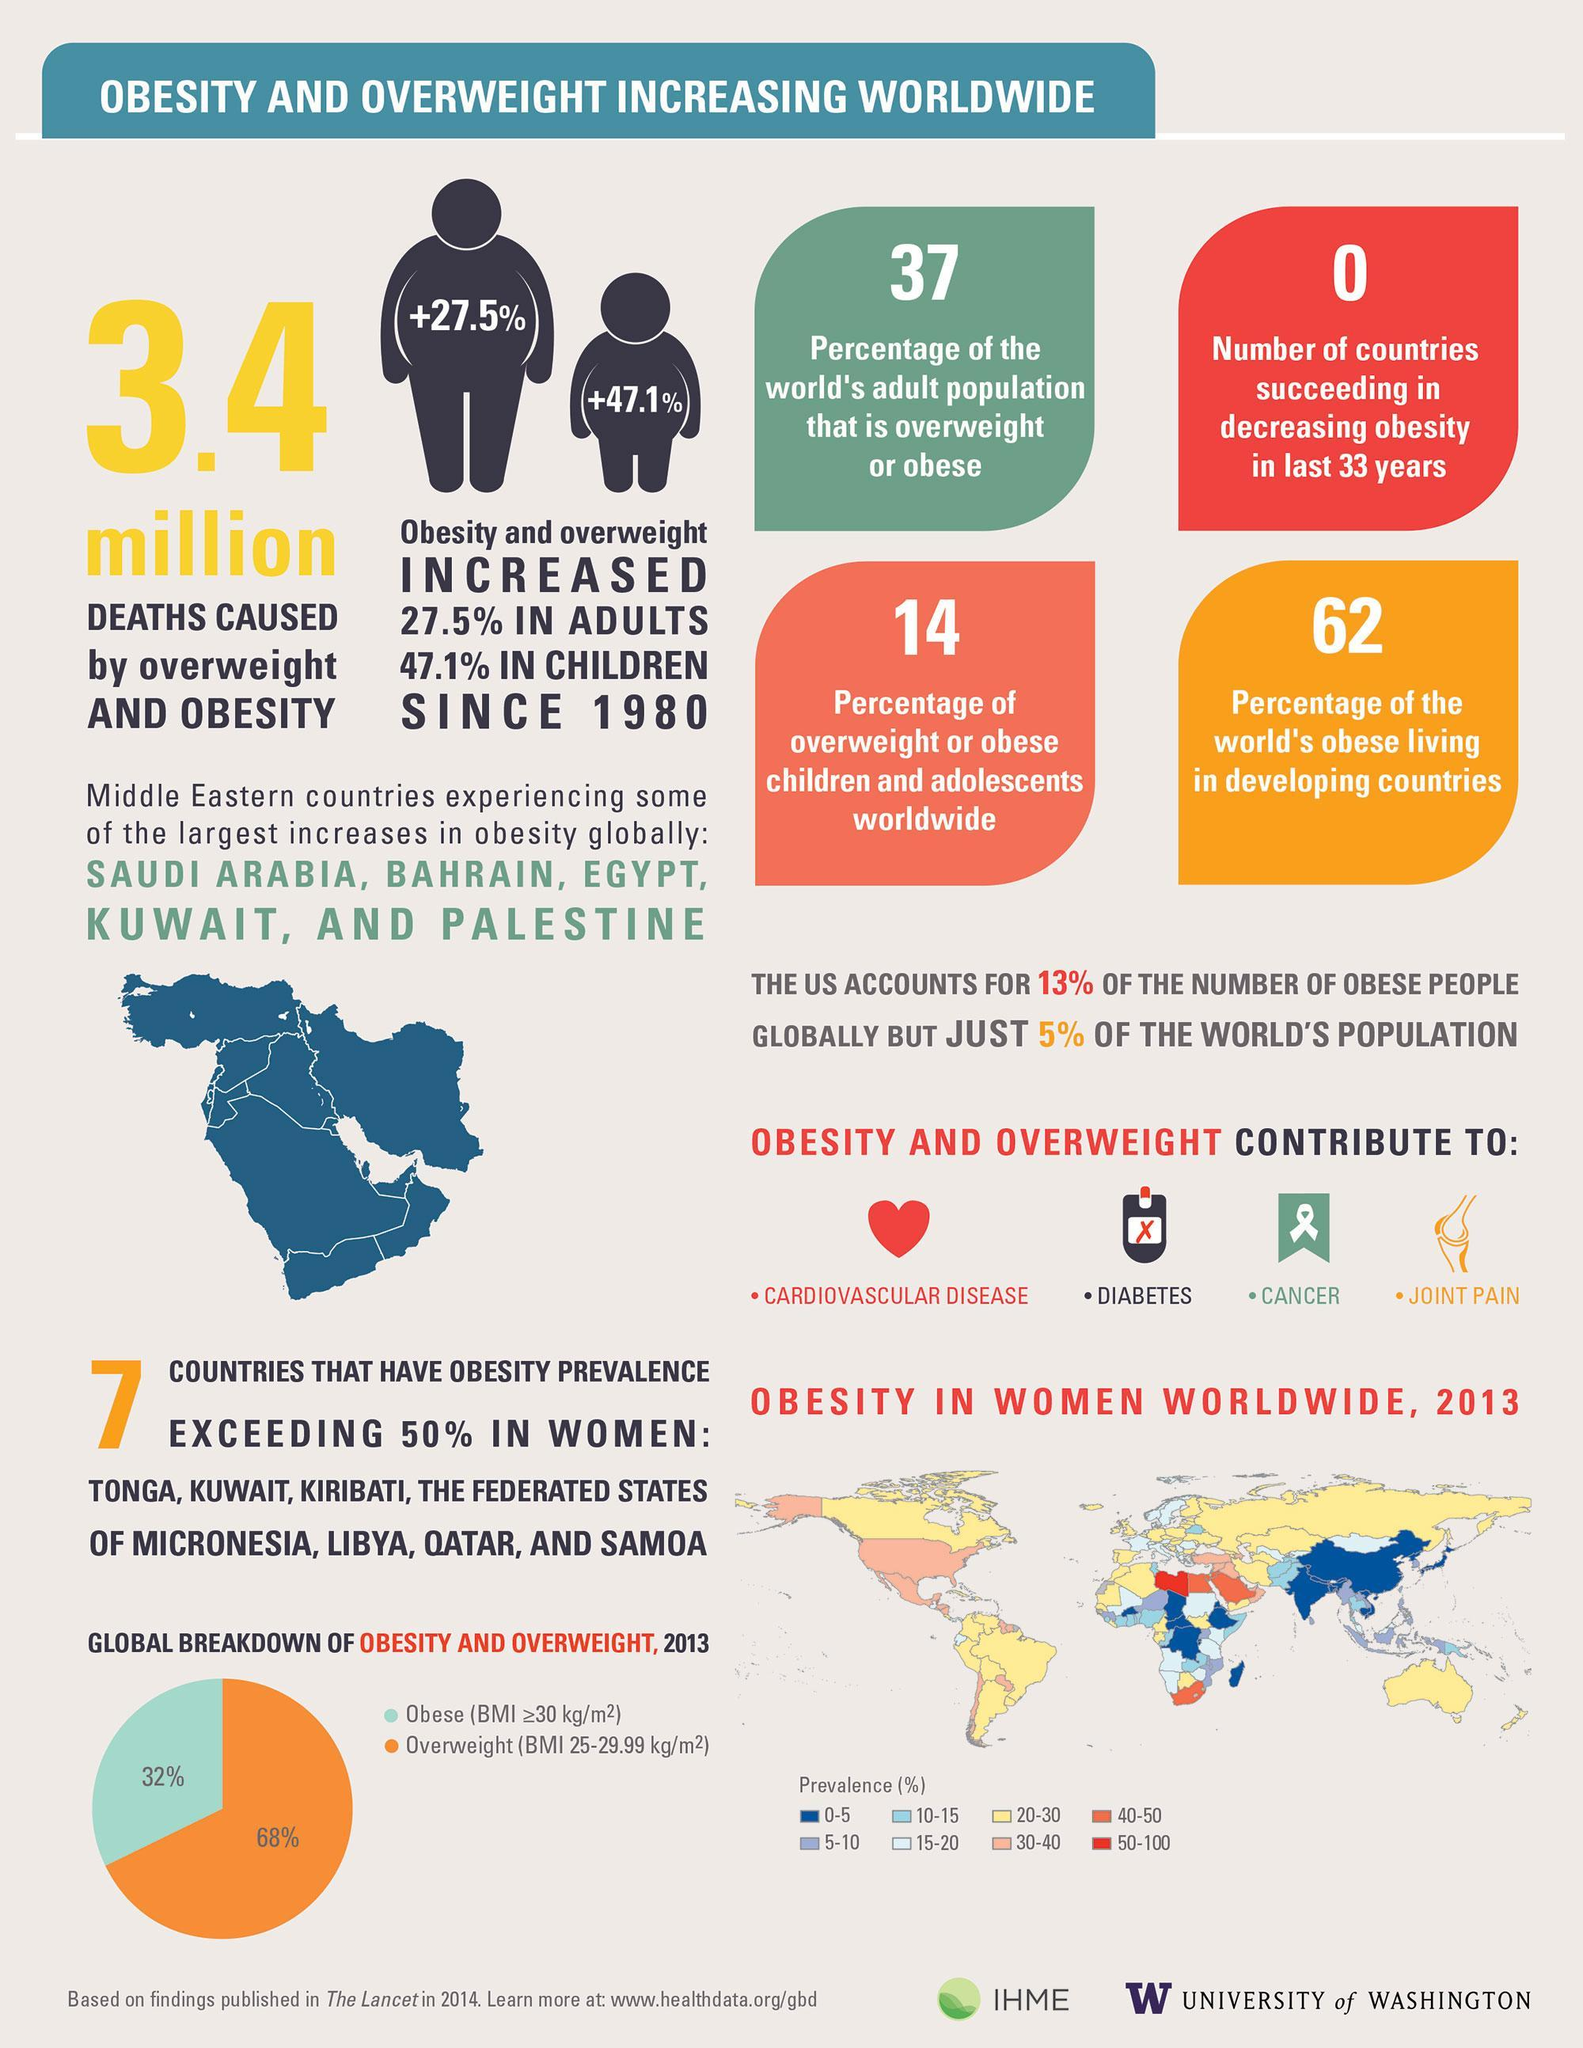Which country has the highest prevalence of obesity?
Answer the question with a short phrase. Libya What is the prevalence percentage of obesity in India? 0-5 What is the total percentage of obese or overweight adults, children and adolescents? 51% What is the prevalence percentage of obesity in the US? 30-40 